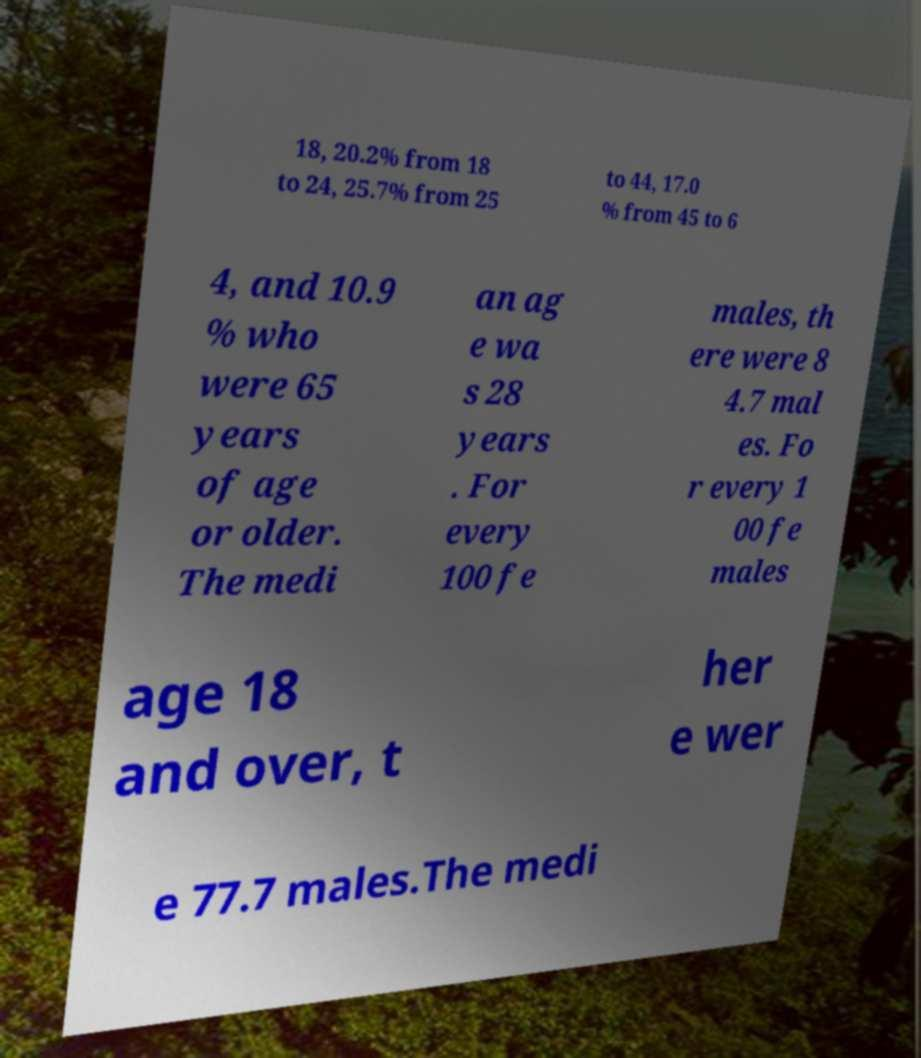Can you read and provide the text displayed in the image?This photo seems to have some interesting text. Can you extract and type it out for me? 18, 20.2% from 18 to 24, 25.7% from 25 to 44, 17.0 % from 45 to 6 4, and 10.9 % who were 65 years of age or older. The medi an ag e wa s 28 years . For every 100 fe males, th ere were 8 4.7 mal es. Fo r every 1 00 fe males age 18 and over, t her e wer e 77.7 males.The medi 